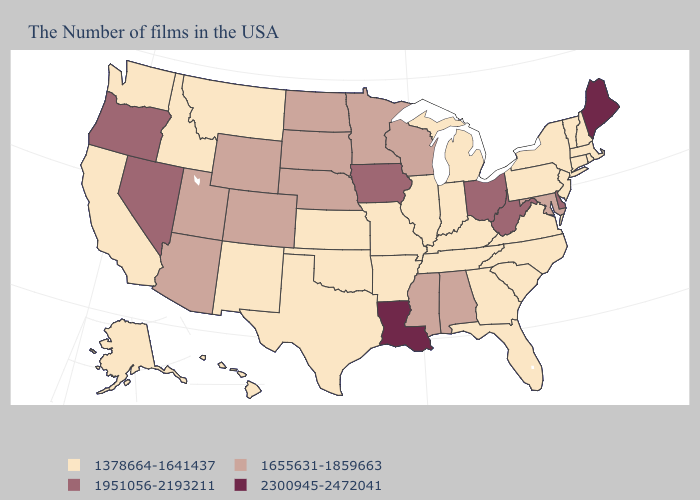How many symbols are there in the legend?
Be succinct. 4. Name the states that have a value in the range 2300945-2472041?
Be succinct. Maine, Louisiana. Name the states that have a value in the range 1655631-1859663?
Concise answer only. Maryland, Alabama, Wisconsin, Mississippi, Minnesota, Nebraska, South Dakota, North Dakota, Wyoming, Colorado, Utah, Arizona. Among the states that border Nebraska , does Missouri have the lowest value?
Keep it brief. Yes. What is the lowest value in states that border Vermont?
Answer briefly. 1378664-1641437. Name the states that have a value in the range 1951056-2193211?
Quick response, please. Delaware, West Virginia, Ohio, Iowa, Nevada, Oregon. Does the map have missing data?
Quick response, please. No. Which states have the lowest value in the USA?
Keep it brief. Massachusetts, Rhode Island, New Hampshire, Vermont, Connecticut, New York, New Jersey, Pennsylvania, Virginia, North Carolina, South Carolina, Florida, Georgia, Michigan, Kentucky, Indiana, Tennessee, Illinois, Missouri, Arkansas, Kansas, Oklahoma, Texas, New Mexico, Montana, Idaho, California, Washington, Alaska, Hawaii. Name the states that have a value in the range 2300945-2472041?
Quick response, please. Maine, Louisiana. Does Connecticut have a higher value than Florida?
Keep it brief. No. What is the lowest value in the USA?
Be succinct. 1378664-1641437. What is the value of Georgia?
Short answer required. 1378664-1641437. What is the value of Arizona?
Answer briefly. 1655631-1859663. What is the value of North Carolina?
Short answer required. 1378664-1641437. 